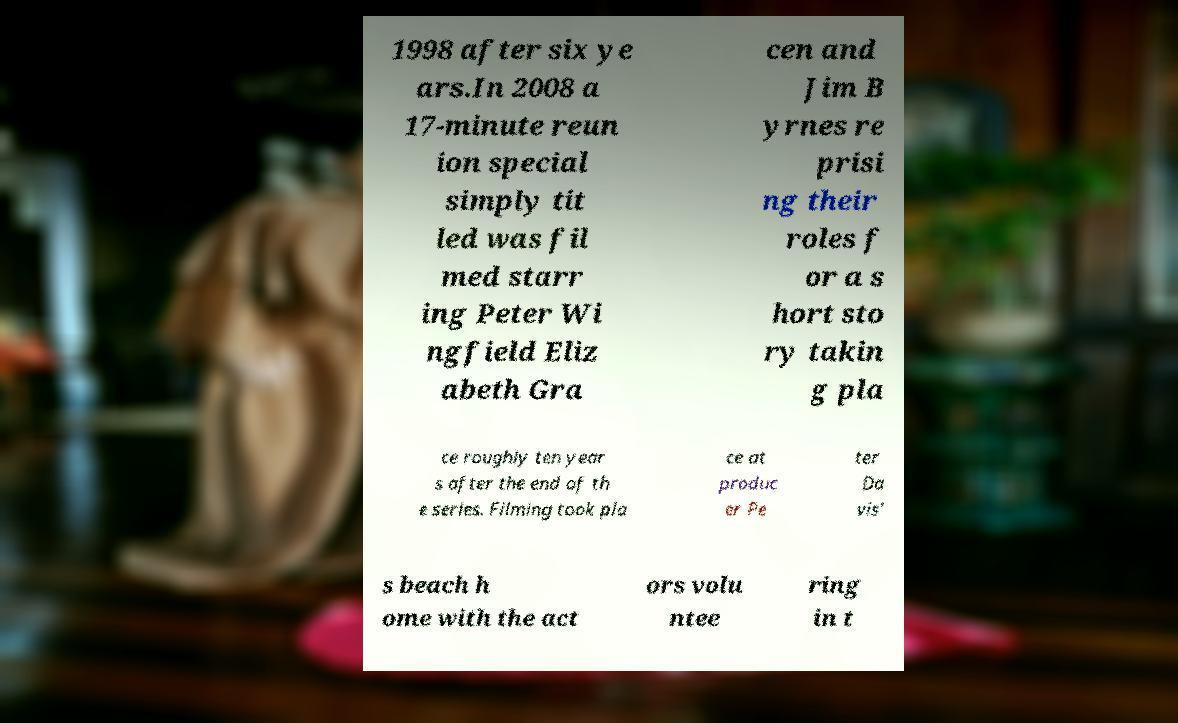Can you read and provide the text displayed in the image?This photo seems to have some interesting text. Can you extract and type it out for me? 1998 after six ye ars.In 2008 a 17-minute reun ion special simply tit led was fil med starr ing Peter Wi ngfield Eliz abeth Gra cen and Jim B yrnes re prisi ng their roles f or a s hort sto ry takin g pla ce roughly ten year s after the end of th e series. Filming took pla ce at produc er Pe ter Da vis' s beach h ome with the act ors volu ntee ring in t 